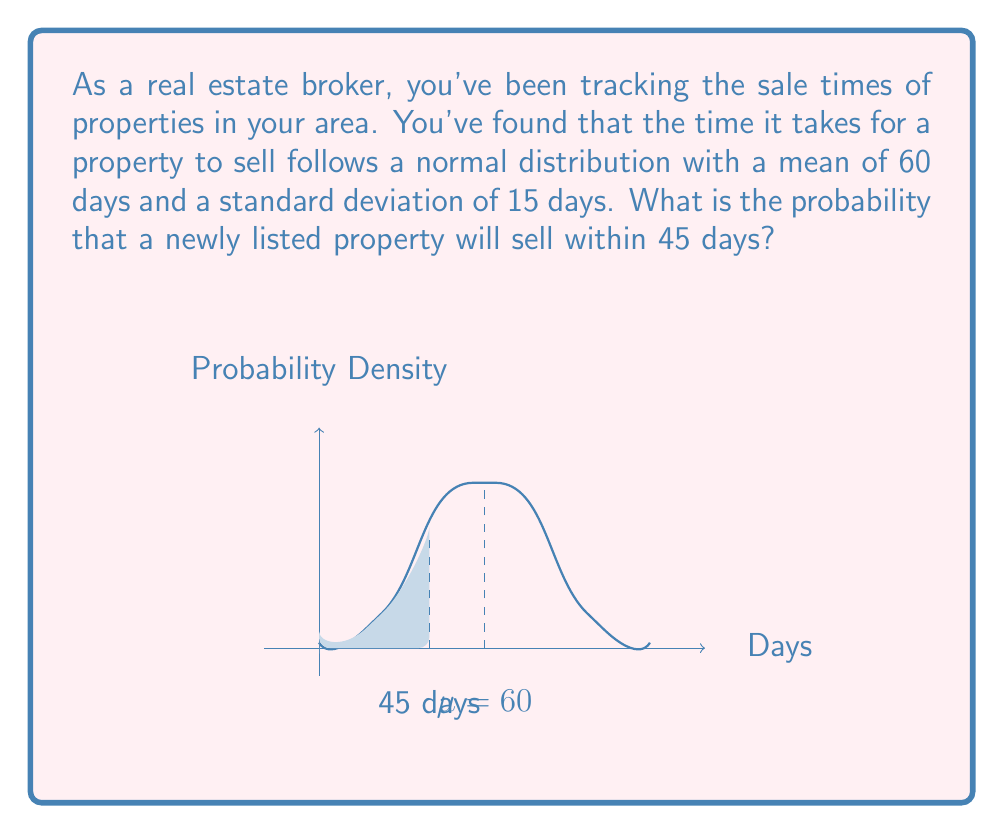Can you solve this math problem? To solve this problem, we'll use the properties of the normal distribution and the concept of z-scores.

1) We're given:
   - Mean (μ) = 60 days
   - Standard deviation (σ) = 15 days
   - We want to find P(X ≤ 45), where X is the time to sell

2) First, we need to calculate the z-score for 45 days:

   $$z = \frac{x - \mu}{\sigma} = \frac{45 - 60}{15} = -1$$

3) Now, we need to find the probability that corresponds to this z-score. This is equivalent to finding the area under the standard normal curve to the left of z = -1.

4) We can use a standard normal table or a calculator to find this probability:

   $$P(Z \leq -1) \approx 0.1587$$

5) Therefore, the probability that a property will sell within 45 days is approximately 0.1587 or 15.87%.

This means that based on the historical data, about 15.87% of properties are expected to sell within 45 days of being listed.
Answer: 0.1587 or 15.87% 